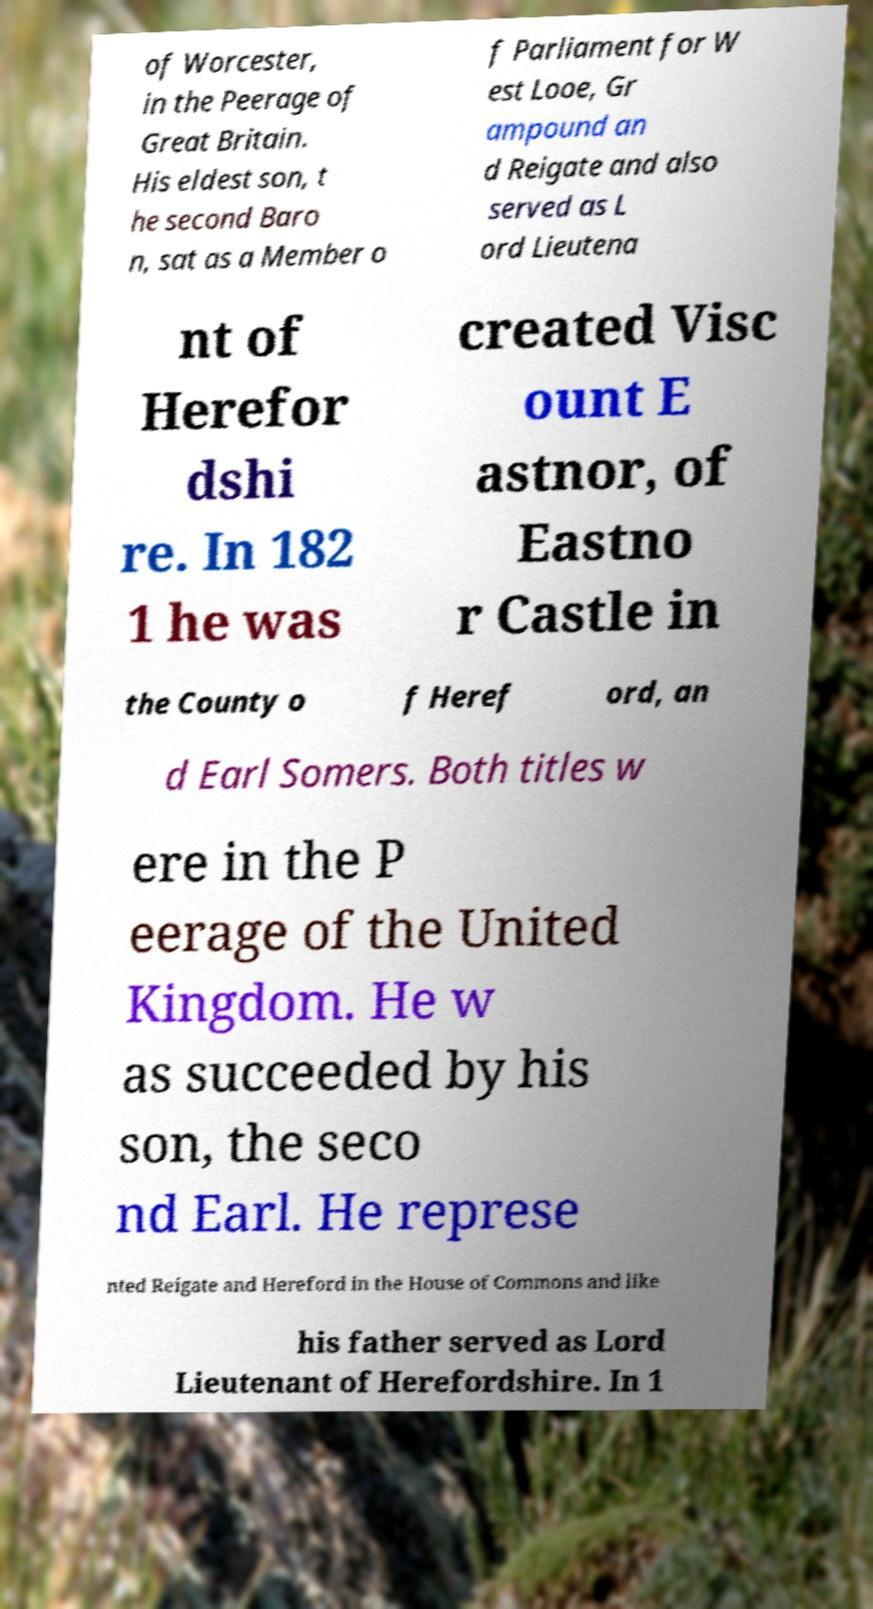What messages or text are displayed in this image? I need them in a readable, typed format. of Worcester, in the Peerage of Great Britain. His eldest son, t he second Baro n, sat as a Member o f Parliament for W est Looe, Gr ampound an d Reigate and also served as L ord Lieutena nt of Herefor dshi re. In 182 1 he was created Visc ount E astnor, of Eastno r Castle in the County o f Heref ord, an d Earl Somers. Both titles w ere in the P eerage of the United Kingdom. He w as succeeded by his son, the seco nd Earl. He represe nted Reigate and Hereford in the House of Commons and like his father served as Lord Lieutenant of Herefordshire. In 1 